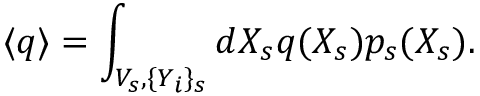Convert formula to latex. <formula><loc_0><loc_0><loc_500><loc_500>\langle q \rangle = \int _ { V _ { s } , \{ Y _ { i } \} _ { s } } d X _ { s } q ( X _ { s } ) p _ { s } ( X _ { s } ) .</formula> 